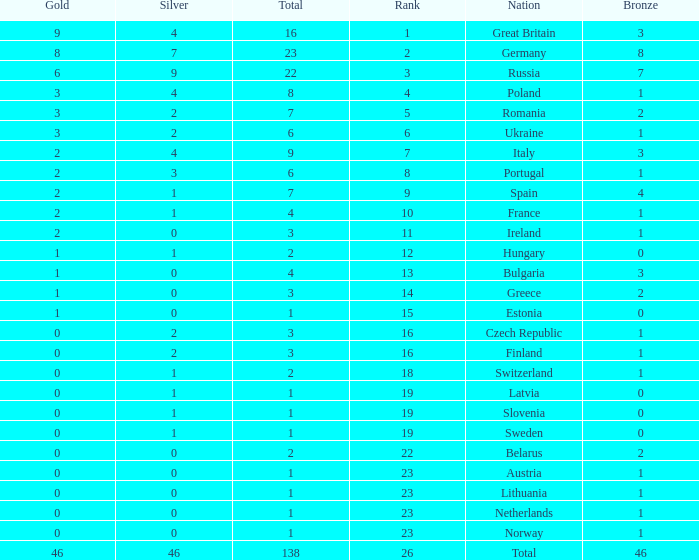What is the average rank when the bronze is larger than 1, and silver is less than 0? None. 